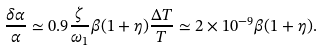Convert formula to latex. <formula><loc_0><loc_0><loc_500><loc_500>\frac { \delta \alpha } { \alpha } \simeq 0 . 9 \frac { \zeta } { \omega _ { 1 } } \beta ( 1 + \eta ) \frac { \Delta T } { T } \simeq 2 \times 1 0 ^ { - 9 } \beta ( 1 + \eta ) .</formula> 